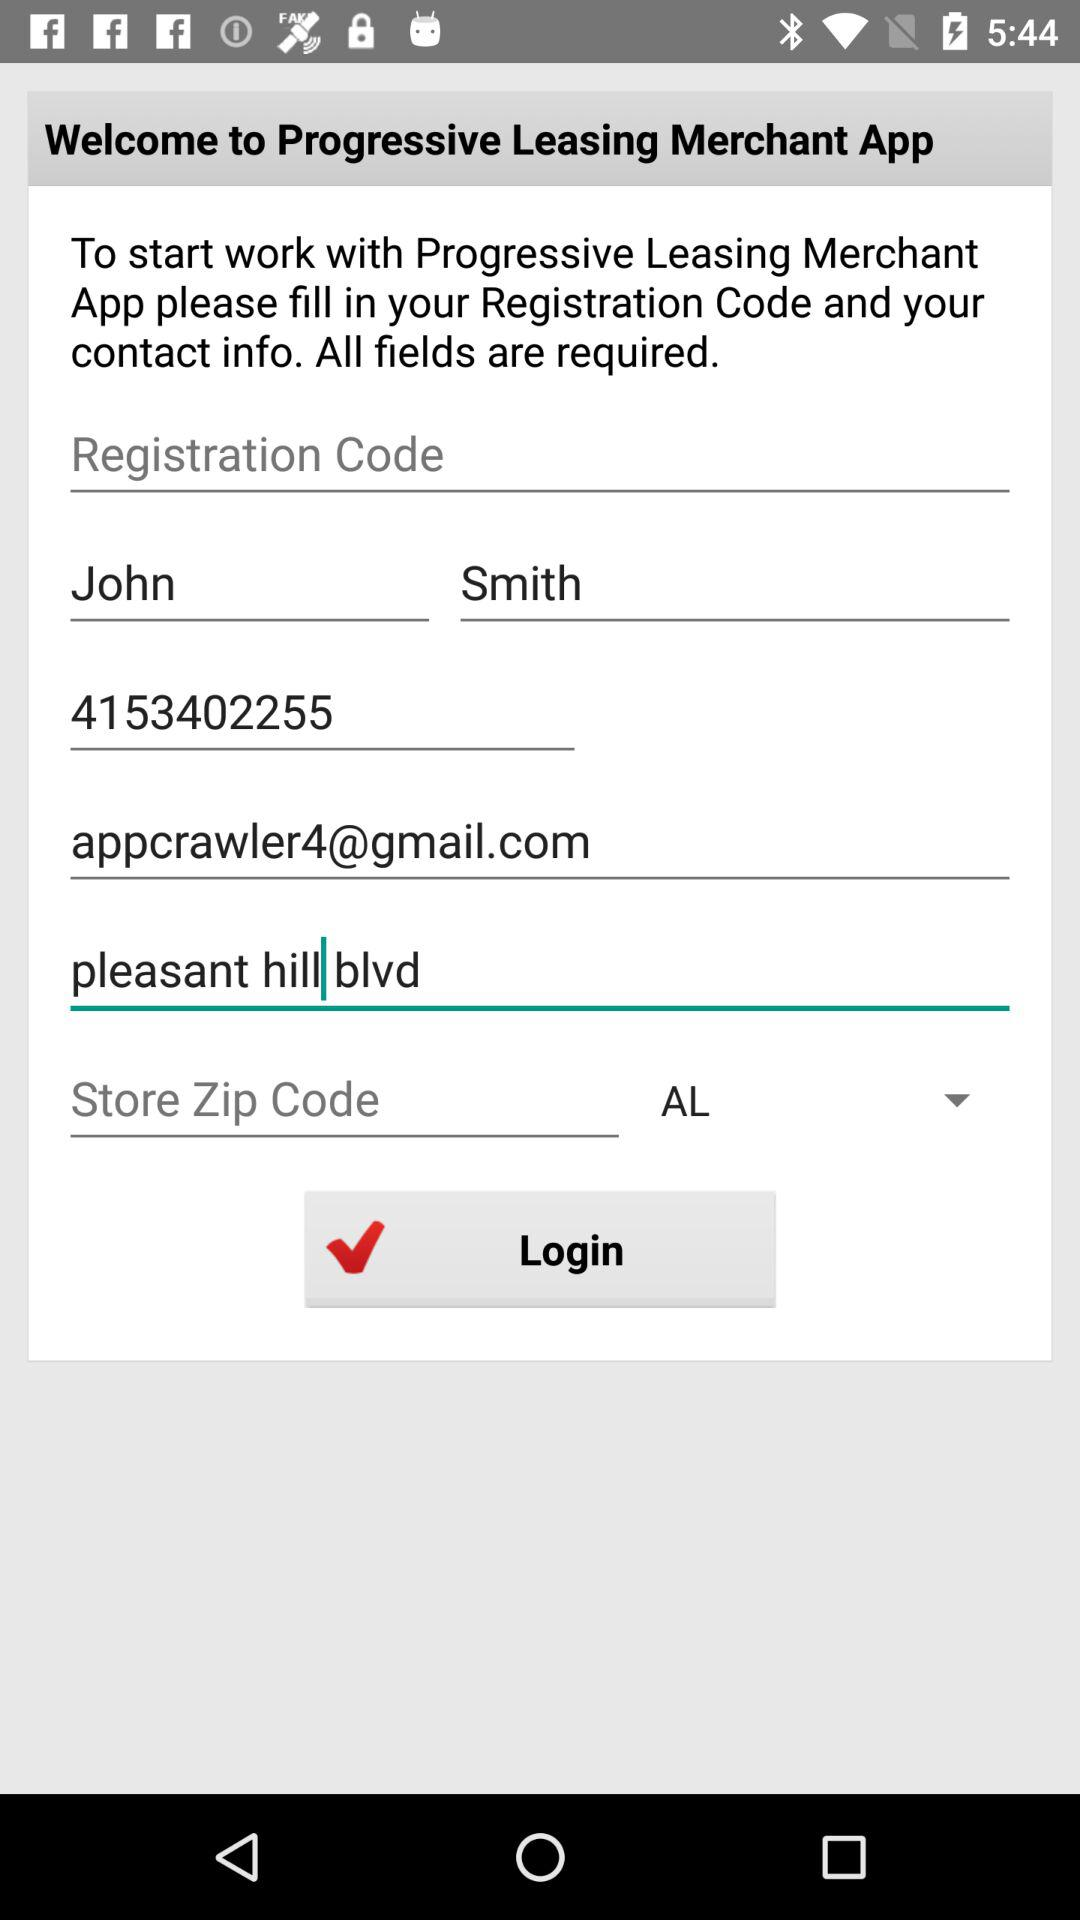What is the contact number? The contact number is 4153402255. 